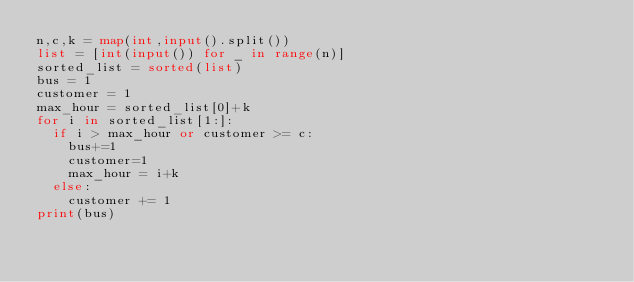Convert code to text. <code><loc_0><loc_0><loc_500><loc_500><_Python_>n,c,k = map(int,input().split())
list = [int(input()) for _ in range(n)]
sorted_list = sorted(list)
bus = 1
customer = 1
max_hour = sorted_list[0]+k
for i in sorted_list[1:]:
  if i > max_hour or customer >= c:
    bus+=1
    customer=1
    max_hour = i+k
  else:
    customer += 1
print(bus)</code> 